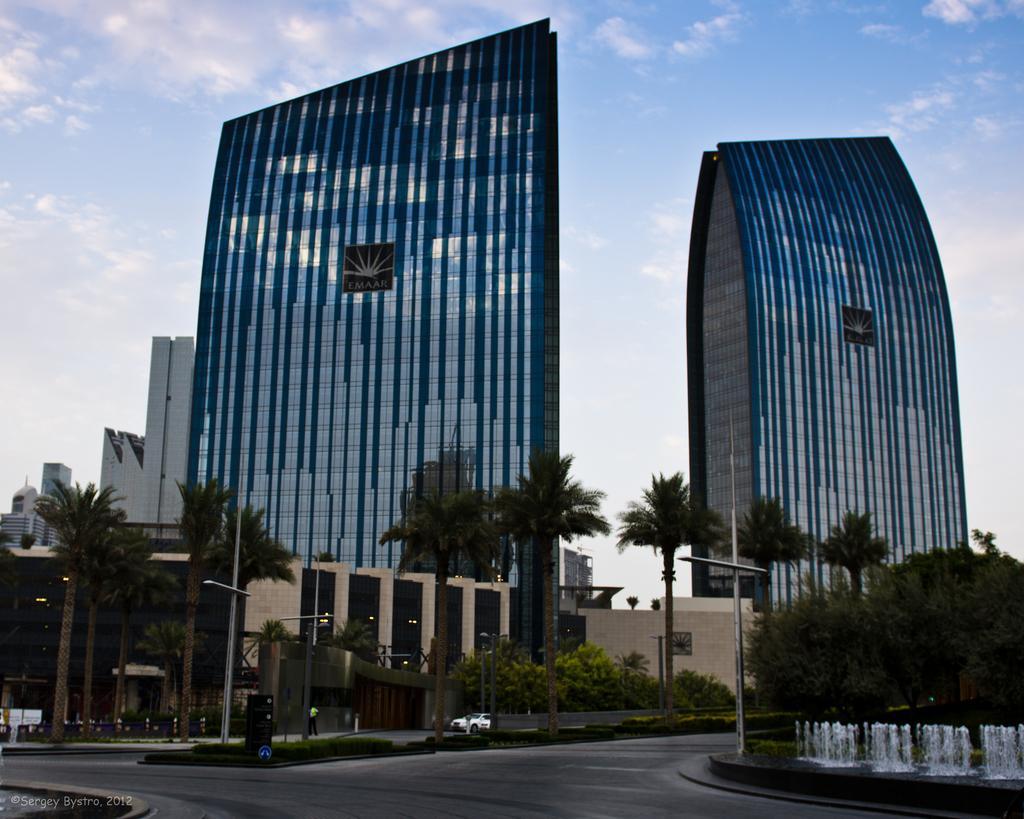In one or two sentences, can you explain what this image depicts? These are the buildings with the glass doors. I can see the trees and bushes. This looks like a water fountain. I can see the poles. Here is a person standing. I think this is a name board. This looks like a vehicle on the road. At the bottom left corner of the image, I can see the watermark. This is the road. 